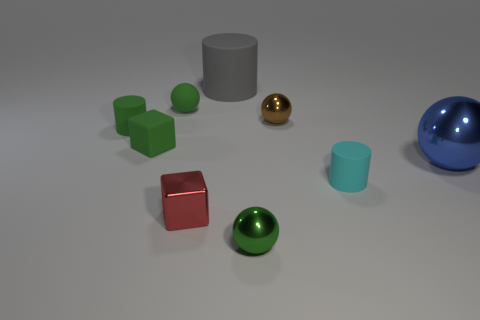There is a small thing that is behind the tiny shiny cube and in front of the green cube; what material is it?
Your response must be concise. Rubber. Are there any large brown rubber things of the same shape as the large blue object?
Ensure brevity in your answer.  No. There is a small green matte object that is in front of the small green matte cylinder; is there a tiny thing that is on the right side of it?
Ensure brevity in your answer.  Yes. What number of small brown objects are made of the same material as the large blue thing?
Your answer should be very brief. 1. Is there a small red shiny thing?
Your answer should be very brief. Yes. What number of big matte cylinders are the same color as the big rubber thing?
Your answer should be very brief. 0. Is the red thing made of the same material as the small sphere in front of the brown ball?
Provide a succinct answer. Yes. Are there more tiny cylinders that are in front of the tiny red thing than big purple matte blocks?
Keep it short and to the point. No. Do the big rubber cylinder and the small cylinder that is behind the blue object have the same color?
Keep it short and to the point. No. Are there an equal number of cubes that are on the left side of the tiny green matte cube and large spheres behind the tiny brown metal object?
Your response must be concise. Yes. 